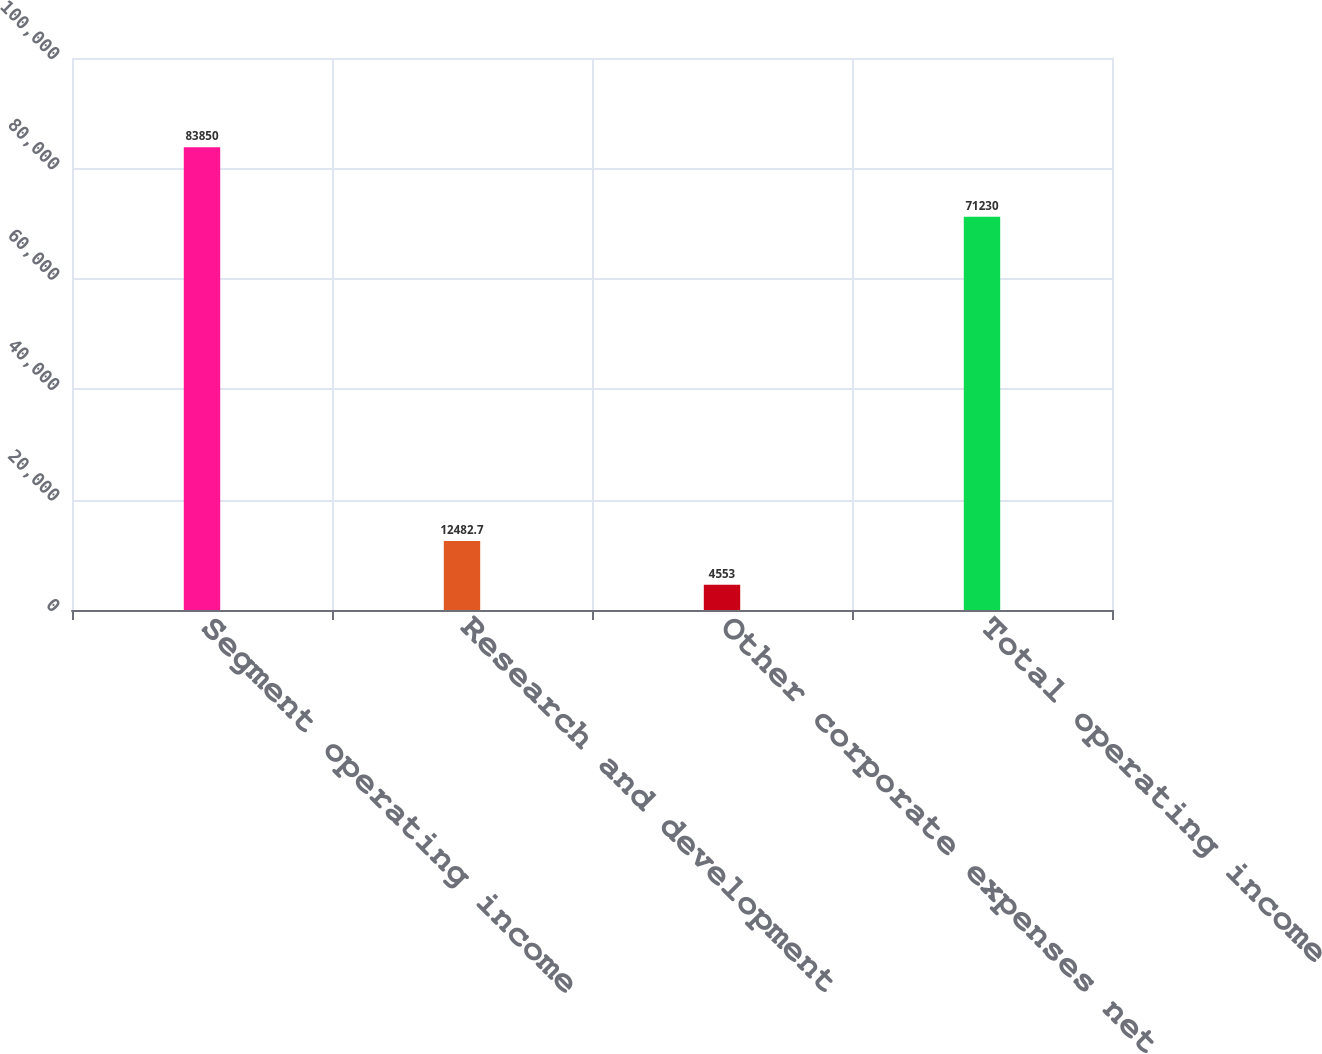<chart> <loc_0><loc_0><loc_500><loc_500><bar_chart><fcel>Segment operating income<fcel>Research and development<fcel>Other corporate expenses net<fcel>Total operating income<nl><fcel>83850<fcel>12482.7<fcel>4553<fcel>71230<nl></chart> 